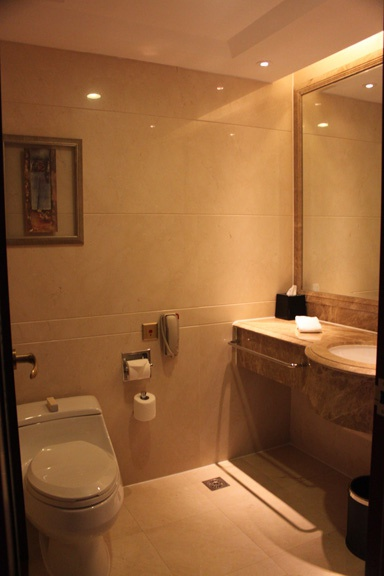Describe the objects in this image and their specific colors. I can see toilet in maroon, brown, and gray tones and sink in maroon, tan, and red tones in this image. 